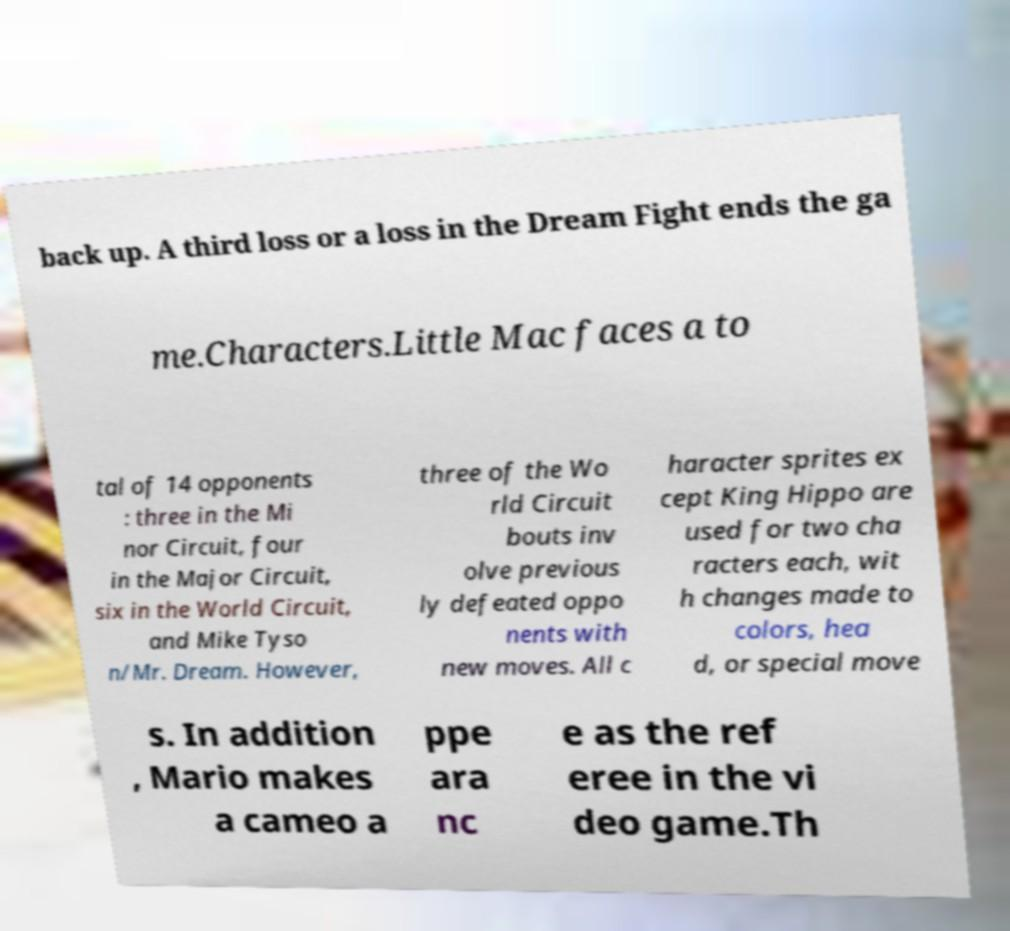For documentation purposes, I need the text within this image transcribed. Could you provide that? back up. A third loss or a loss in the Dream Fight ends the ga me.Characters.Little Mac faces a to tal of 14 opponents : three in the Mi nor Circuit, four in the Major Circuit, six in the World Circuit, and Mike Tyso n/Mr. Dream. However, three of the Wo rld Circuit bouts inv olve previous ly defeated oppo nents with new moves. All c haracter sprites ex cept King Hippo are used for two cha racters each, wit h changes made to colors, hea d, or special move s. In addition , Mario makes a cameo a ppe ara nc e as the ref eree in the vi deo game.Th 